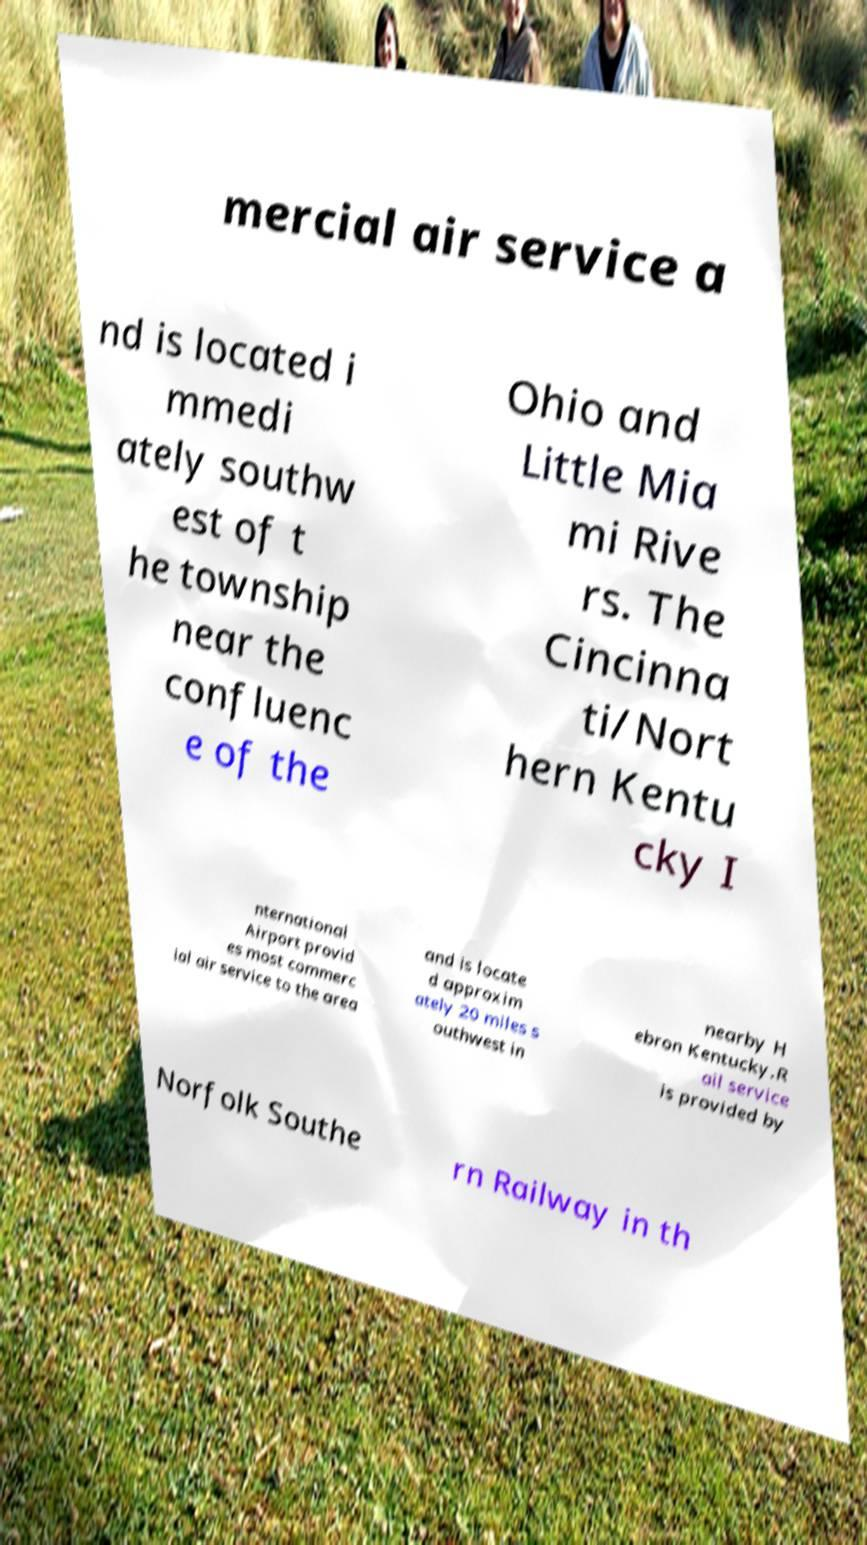Could you assist in decoding the text presented in this image and type it out clearly? mercial air service a nd is located i mmedi ately southw est of t he township near the confluenc e of the Ohio and Little Mia mi Rive rs. The Cincinna ti/Nort hern Kentu cky I nternational Airport provid es most commerc ial air service to the area and is locate d approxim ately 20 miles s outhwest in nearby H ebron Kentucky.R ail service is provided by Norfolk Southe rn Railway in th 